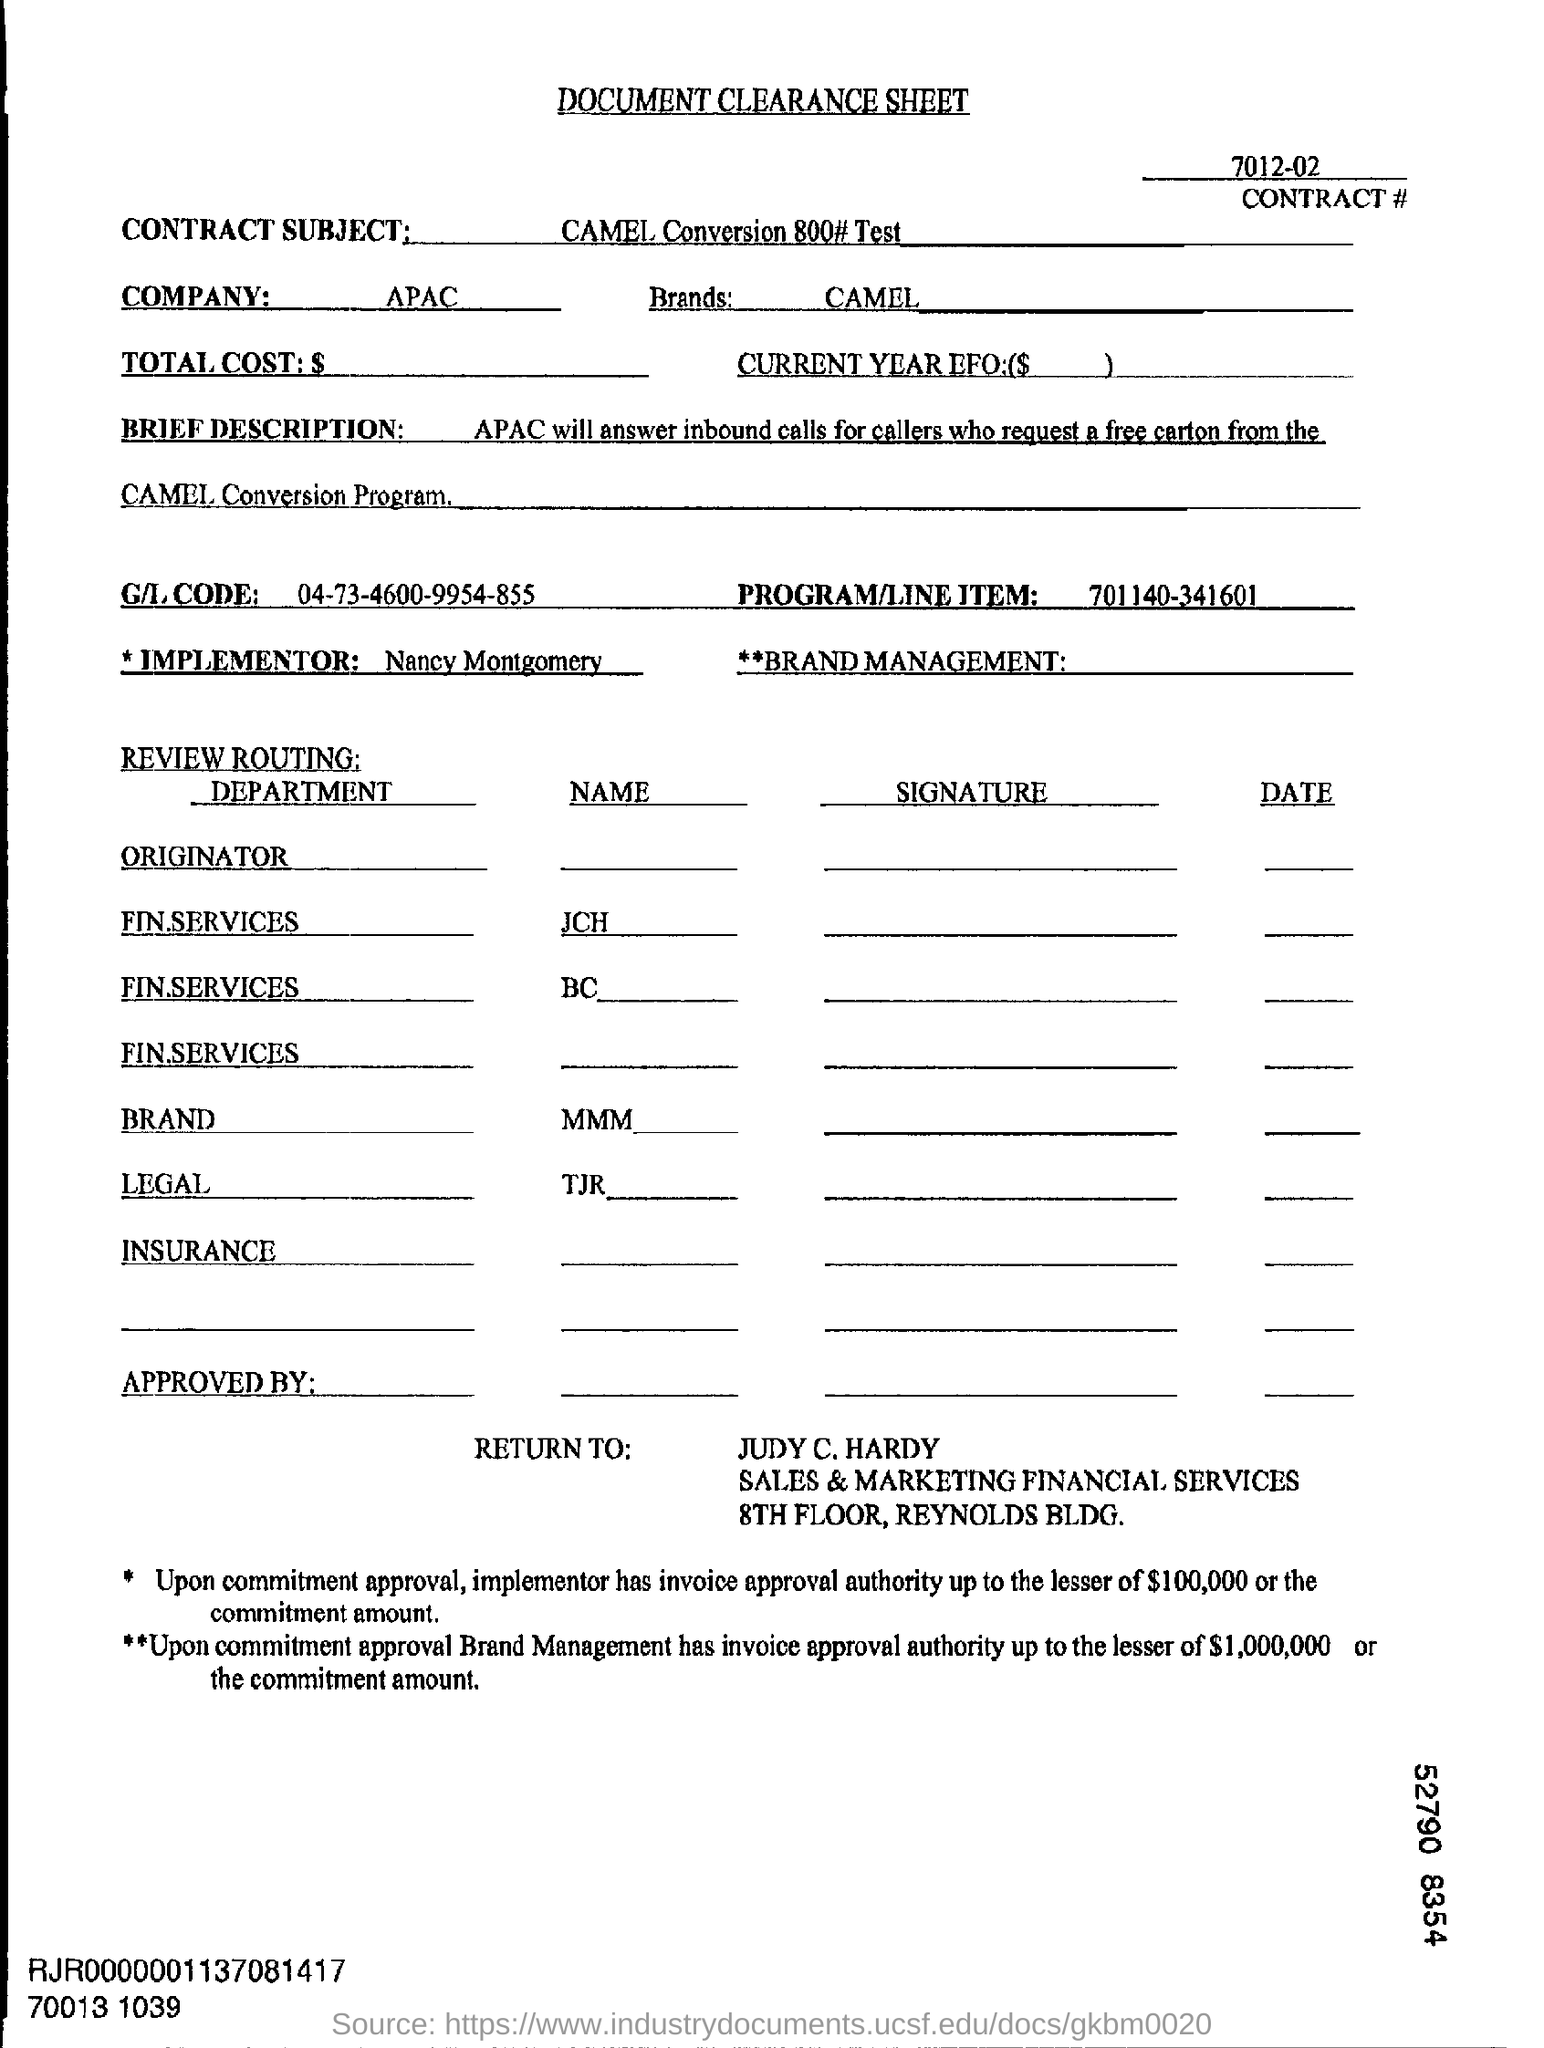Give some essential details in this illustration. The document clearance sheet is named 'DOCUMENT CLEARANCE SHEET'. I am not certain, but I believe the company in question is located in the APAC region. The company name mentioned in the form is APAC. The brand name is Camel. 